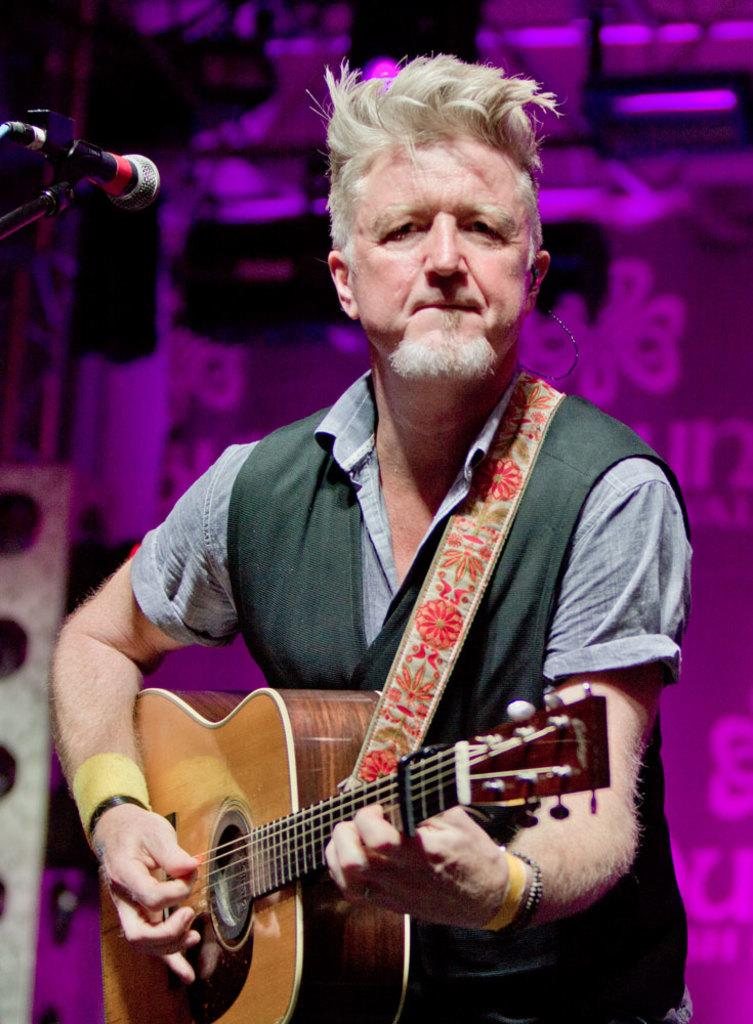Who is the main subject in the image? There is a person in the center of the image. What is the person holding in the image? The person is holding a guitar. What other object can be seen in the image? There is a microphone on the left side of the image. How many feet does the queen have in the image? There is no queen present in the image, and therefore no feet to count. 